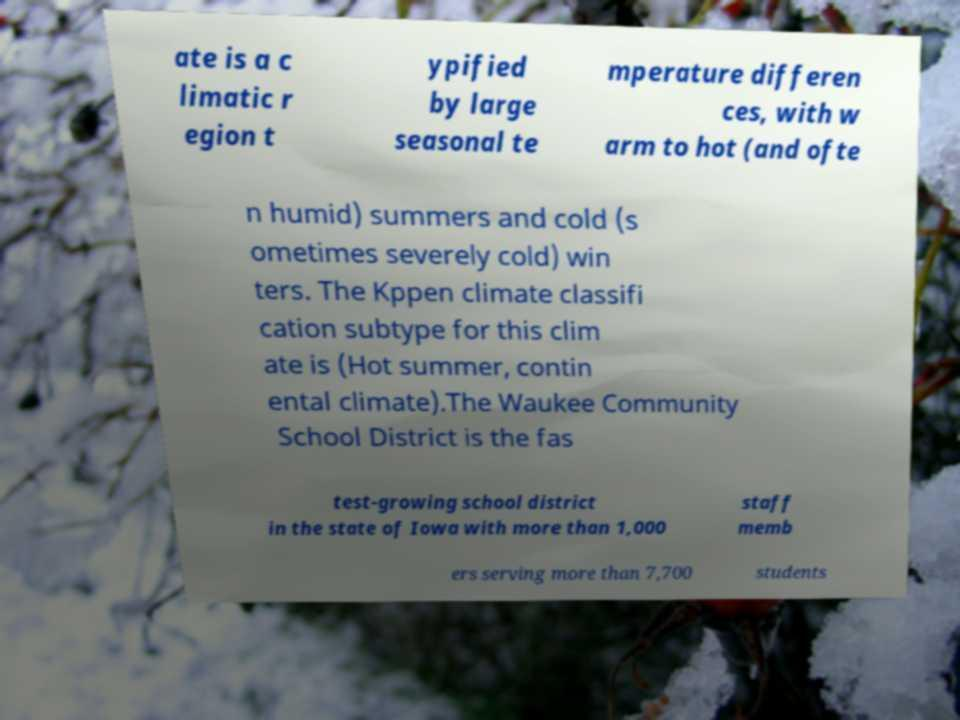Could you extract and type out the text from this image? ate is a c limatic r egion t ypified by large seasonal te mperature differen ces, with w arm to hot (and ofte n humid) summers and cold (s ometimes severely cold) win ters. The Kppen climate classifi cation subtype for this clim ate is (Hot summer, contin ental climate).The Waukee Community School District is the fas test-growing school district in the state of Iowa with more than 1,000 staff memb ers serving more than 7,700 students 